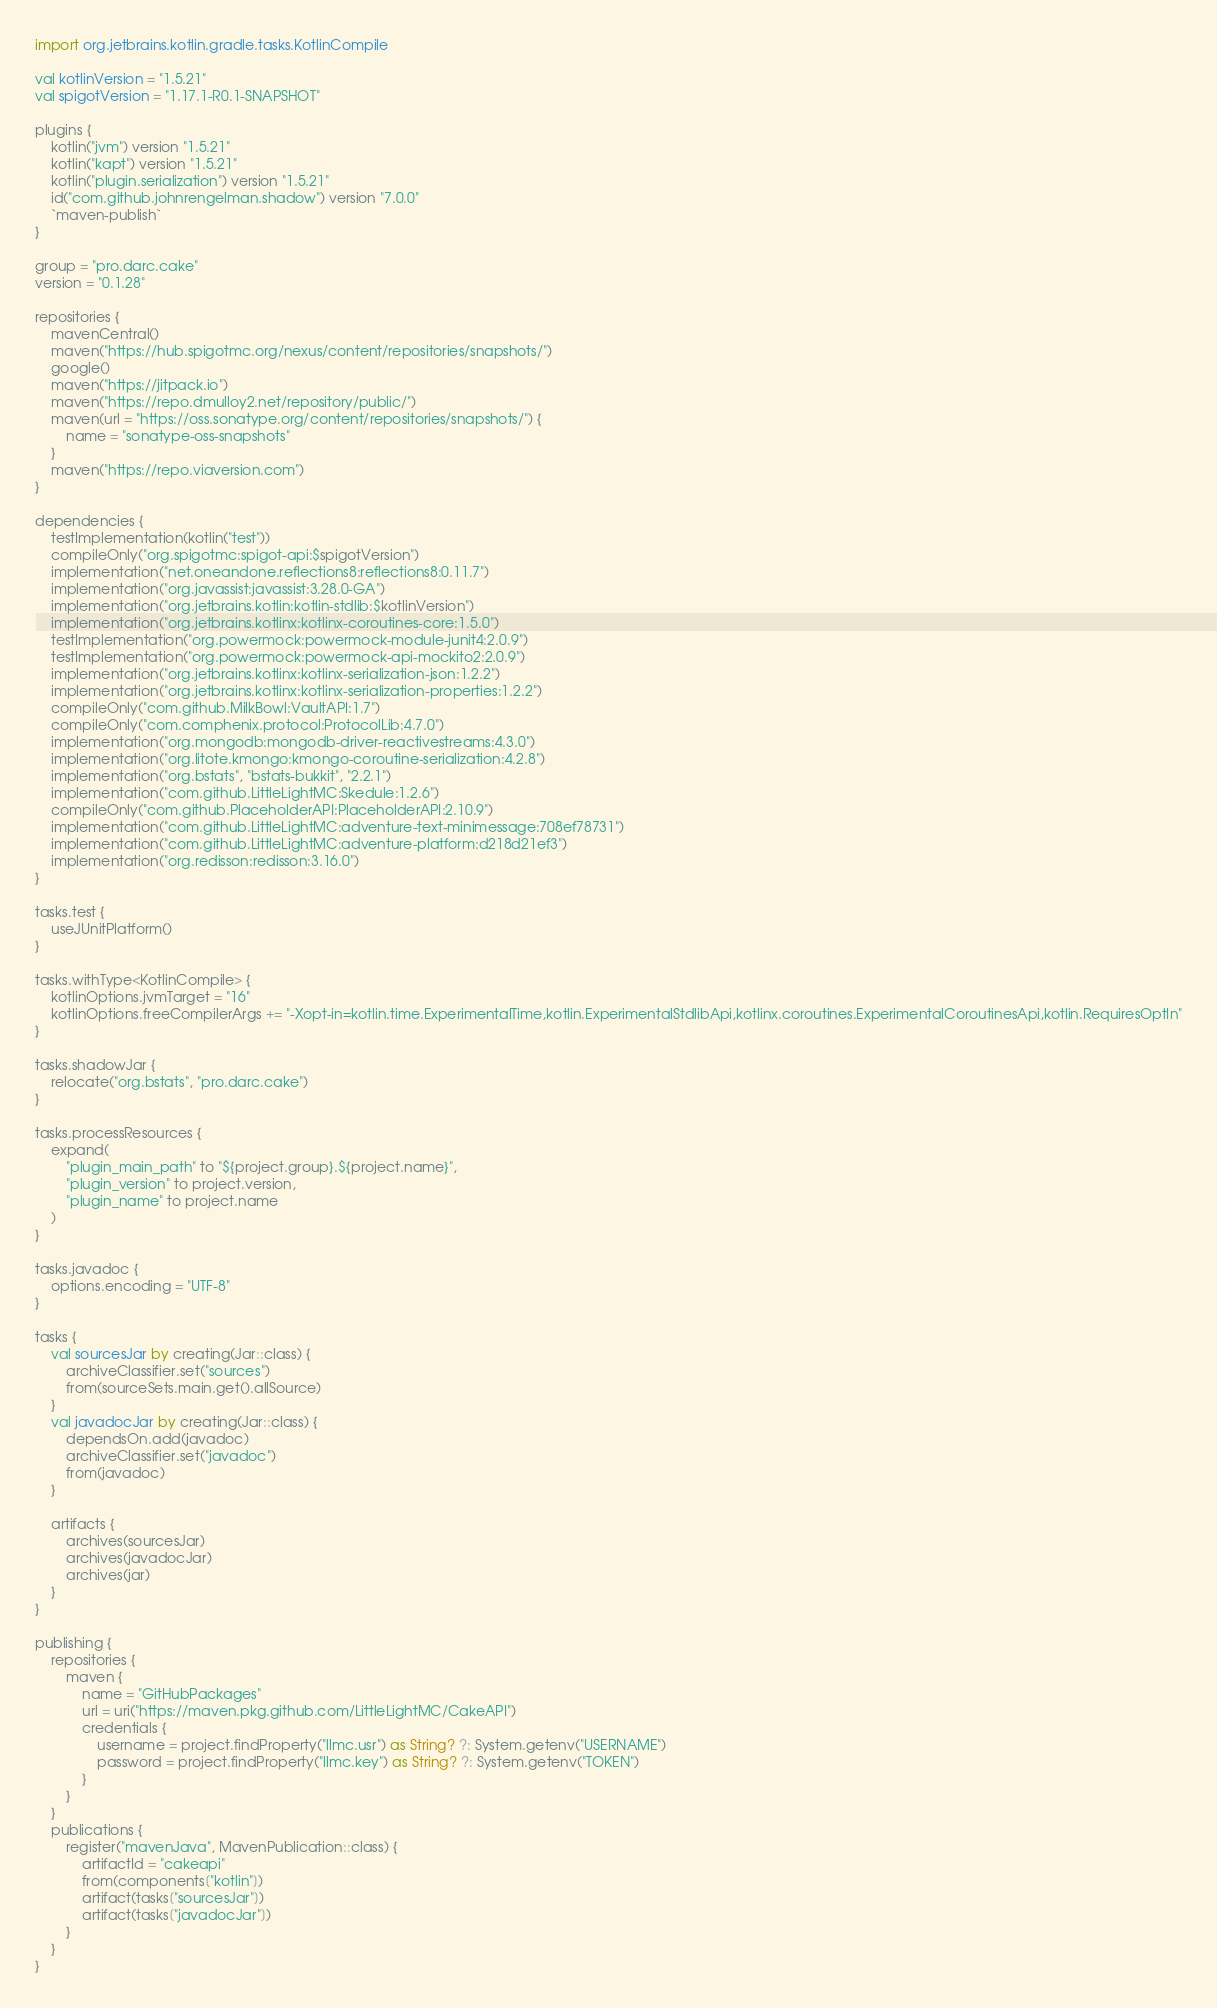Convert code to text. <code><loc_0><loc_0><loc_500><loc_500><_Kotlin_>import org.jetbrains.kotlin.gradle.tasks.KotlinCompile

val kotlinVersion = "1.5.21"
val spigotVersion = "1.17.1-R0.1-SNAPSHOT"

plugins {
    kotlin("jvm") version "1.5.21"
    kotlin("kapt") version "1.5.21"
    kotlin("plugin.serialization") version "1.5.21"
    id("com.github.johnrengelman.shadow") version "7.0.0"
    `maven-publish`
}

group = "pro.darc.cake"
version = "0.1.28"

repositories {
    mavenCentral()
    maven("https://hub.spigotmc.org/nexus/content/repositories/snapshots/")
    google()
    maven("https://jitpack.io")
    maven("https://repo.dmulloy2.net/repository/public/")
    maven(url = "https://oss.sonatype.org/content/repositories/snapshots/") {
        name = "sonatype-oss-snapshots"
    }
    maven("https://repo.viaversion.com")
}

dependencies {
    testImplementation(kotlin("test"))
    compileOnly("org.spigotmc:spigot-api:$spigotVersion")
    implementation("net.oneandone.reflections8:reflections8:0.11.7")
    implementation("org.javassist:javassist:3.28.0-GA")
    implementation("org.jetbrains.kotlin:kotlin-stdlib:$kotlinVersion")
    implementation("org.jetbrains.kotlinx:kotlinx-coroutines-core:1.5.0")
    testImplementation("org.powermock:powermock-module-junit4:2.0.9")
    testImplementation("org.powermock:powermock-api-mockito2:2.0.9")
    implementation("org.jetbrains.kotlinx:kotlinx-serialization-json:1.2.2")
    implementation("org.jetbrains.kotlinx:kotlinx-serialization-properties:1.2.2")
    compileOnly("com.github.MilkBowl:VaultAPI:1.7")
    compileOnly("com.comphenix.protocol:ProtocolLib:4.7.0")
    implementation("org.mongodb:mongodb-driver-reactivestreams:4.3.0")
    implementation("org.litote.kmongo:kmongo-coroutine-serialization:4.2.8")
    implementation("org.bstats", "bstats-bukkit", "2.2.1")
    implementation("com.github.LittleLightMC:Skedule:1.2.6")
    compileOnly("com.github.PlaceholderAPI:PlaceholderAPI:2.10.9")
    implementation("com.github.LittleLightMC:adventure-text-minimessage:708ef78731")
    implementation("com.github.LittleLightMC:adventure-platform:d218d21ef3")
    implementation("org.redisson:redisson:3.16.0")
}

tasks.test {
    useJUnitPlatform()
}

tasks.withType<KotlinCompile> {
    kotlinOptions.jvmTarget = "16"
    kotlinOptions.freeCompilerArgs += "-Xopt-in=kotlin.time.ExperimentalTime,kotlin.ExperimentalStdlibApi,kotlinx.coroutines.ExperimentalCoroutinesApi,kotlin.RequiresOptIn"
}

tasks.shadowJar {
    relocate("org.bstats", "pro.darc.cake")
}

tasks.processResources {
    expand(
        "plugin_main_path" to "${project.group}.${project.name}",
        "plugin_version" to project.version,
        "plugin_name" to project.name
    )
}

tasks.javadoc {
    options.encoding = "UTF-8"
}

tasks {
    val sourcesJar by creating(Jar::class) {
        archiveClassifier.set("sources")
        from(sourceSets.main.get().allSource)
    }
    val javadocJar by creating(Jar::class) {
        dependsOn.add(javadoc)
        archiveClassifier.set("javadoc")
        from(javadoc)
    }

    artifacts {
        archives(sourcesJar)
        archives(javadocJar)
        archives(jar)
    }
}

publishing {
    repositories {
        maven {
            name = "GitHubPackages"
            url = uri("https://maven.pkg.github.com/LittleLightMC/CakeAPI")
            credentials {
                username = project.findProperty("llmc.usr") as String? ?: System.getenv("USERNAME")
                password = project.findProperty("llmc.key") as String? ?: System.getenv("TOKEN")
            }
        }
    }
    publications {
        register("mavenJava", MavenPublication::class) {
            artifactId = "cakeapi"
            from(components["kotlin"])
            artifact(tasks["sourcesJar"])
            artifact(tasks["javadocJar"])
        }
    }
}
</code> 